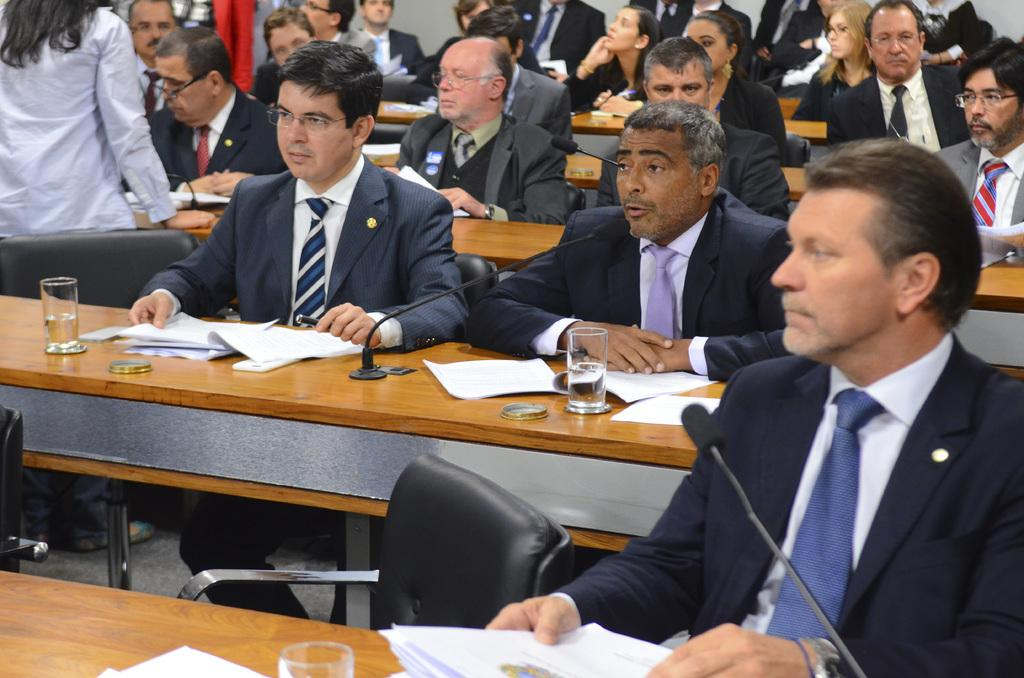How many people are in the image? There are many persons in the image. What are the persons wearing? The persons are wearing black suits. What type of furniture is present in the image? There are benches in the image. What items can be seen on the benches? Papers, glasses, and microphones (mics) are present on the benches. What shape is the activity taking place in the image? There is no specific shape mentioned in the image, and no activity is described. The image only shows many persons wearing black suits, benches, papers, glasses, and microphones on the benches. 